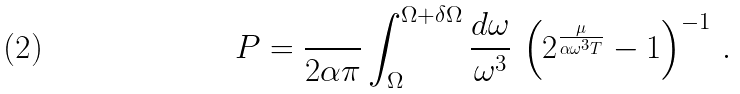<formula> <loc_0><loc_0><loc_500><loc_500>P = \frac { } { 2 \alpha \pi } \int _ { \Omega } ^ { \Omega + \delta \Omega } \frac { d \omega } { \omega ^ { 3 } } \, \left ( 2 ^ { \frac { \mu } { \alpha \omega ^ { 3 } T } } - 1 \right ) ^ { - 1 } \, .</formula> 